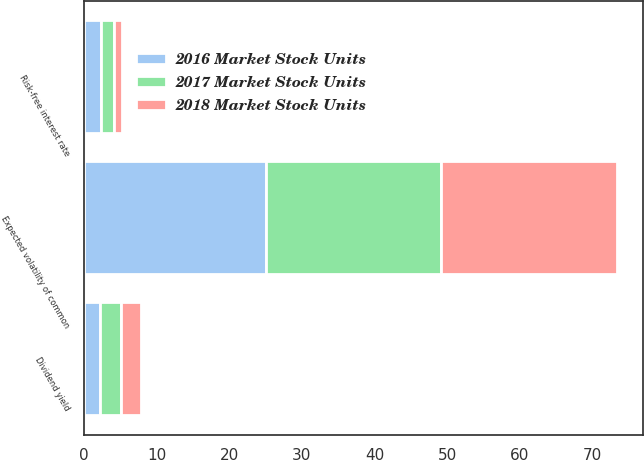<chart> <loc_0><loc_0><loc_500><loc_500><stacked_bar_chart><ecel><fcel>Expected volatility of common<fcel>Risk-free interest rate<fcel>Dividend yield<nl><fcel>2016 Market Stock Units<fcel>25<fcel>2.4<fcel>2.2<nl><fcel>2017 Market Stock Units<fcel>24.1<fcel>1.7<fcel>2.9<nl><fcel>2018 Market Stock Units<fcel>24.2<fcel>1.1<fcel>2.8<nl></chart> 